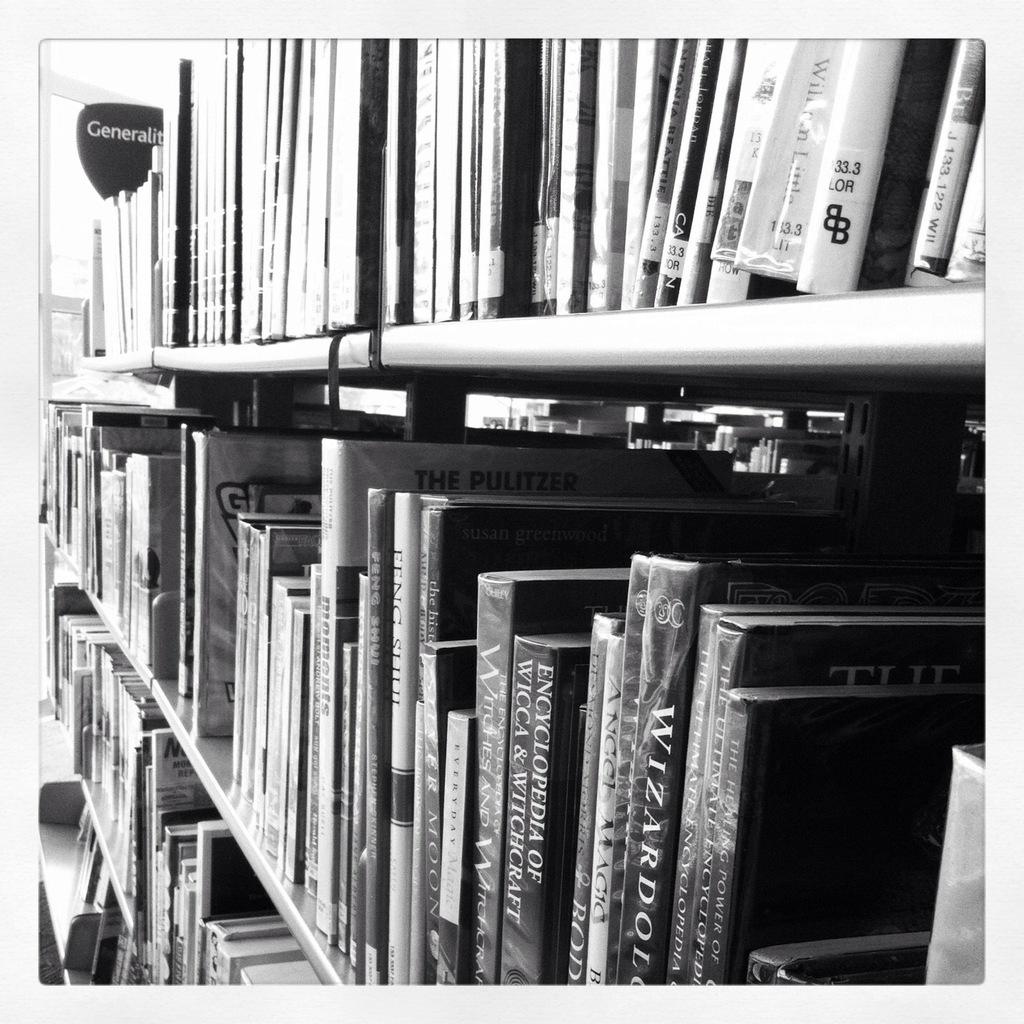<image>
Offer a succinct explanation of the picture presented. Encyclopedia of Wicca and Witchcraft sis on the shelf along with a bunch of other books. 